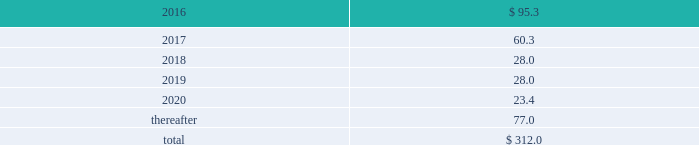Interest expense related to capital lease obligations was $ 1.6 million during the year ended december 31 , 2015 , and $ 1.6 million during both the years ended december 31 , 2014 and 2013 .
Purchase commitments in the table below , we set forth our enforceable and legally binding purchase obligations as of december 31 , 2015 .
Some of the amounts are based on management 2019s estimates and assumptions about these obligations , including their duration , the possibility of renewal , anticipated actions by third parties , and other factors .
Because these estimates and assumptions are necessarily subjective , our actual payments may vary from those reflected in the table .
Purchase orders made in the ordinary course of business are excluded below .
Any amounts for which we are liable under purchase orders are reflected on the consolidated balance sheets as accounts payable and accrued liabilities .
These obligations relate to various purchase agreements for items such as minimum amounts of fiber and energy purchases over periods ranging from one year to 20 years .
Total purchase commitments were as follows ( dollars in millions ) : .
The company purchased a total of $ 299.6 million , $ 265.9 million , and $ 61.7 million during the years ended december 31 , 2015 , 2014 , and 2013 , respectively , under these purchase agreements .
The increase in purchases the increase in purchases under these agreements in 2014 , compared with 2013 , relates to the acquisition of boise in fourth quarter 2013 .
Environmental liabilities the potential costs for various environmental matters are uncertain due to such factors as the unknown magnitude of possible cleanup costs , the complexity and evolving nature of governmental laws and regulations and their interpretations , and the timing , varying costs and effectiveness of alternative cleanup technologies .
From 2006 through 2015 , there were no significant environmental remediation costs at pca 2019s mills and corrugated plants .
At december 31 , 2015 , the company had $ 24.3 million of environmental-related reserves recorded on its consolidated balance sheet .
Of the $ 24.3 million , approximately $ 15.8 million related to environmental-related asset retirement obligations discussed in note 12 , asset retirement obligations , and $ 8.5 million related to our estimate of other environmental contingencies .
The company recorded $ 7.9 million in 201caccrued liabilities 201d and $ 16.4 million in 201cother long-term liabilities 201d on the consolidated balance sheet .
Liabilities recorded for environmental contingencies are estimates of the probable costs based upon available information and assumptions .
Because of these uncertainties , pca 2019s estimates may change .
The company believes that it is not reasonably possible that future environmental expenditures for remediation costs and asset retirement obligations above the $ 24.3 million accrued as of december 31 , 2015 , will have a material impact on its financial condition , results of operations , or cash flows .
Guarantees and indemnifications we provide guarantees , indemnifications , and other assurances to third parties in the normal course of our business .
These include tort indemnifications , environmental assurances , and representations and warranties in commercial agreements .
At december 31 , 2015 , we are not aware of any material liabilities arising from any guarantee , indemnification , or financial assurance we have provided .
If we determined such a liability was probable and subject to reasonable determination , we would accrue for it at that time. .
What percentage of total purchase commitments are due after 2020? 
Computations: (77.0 / 312.0)
Answer: 0.24679. 